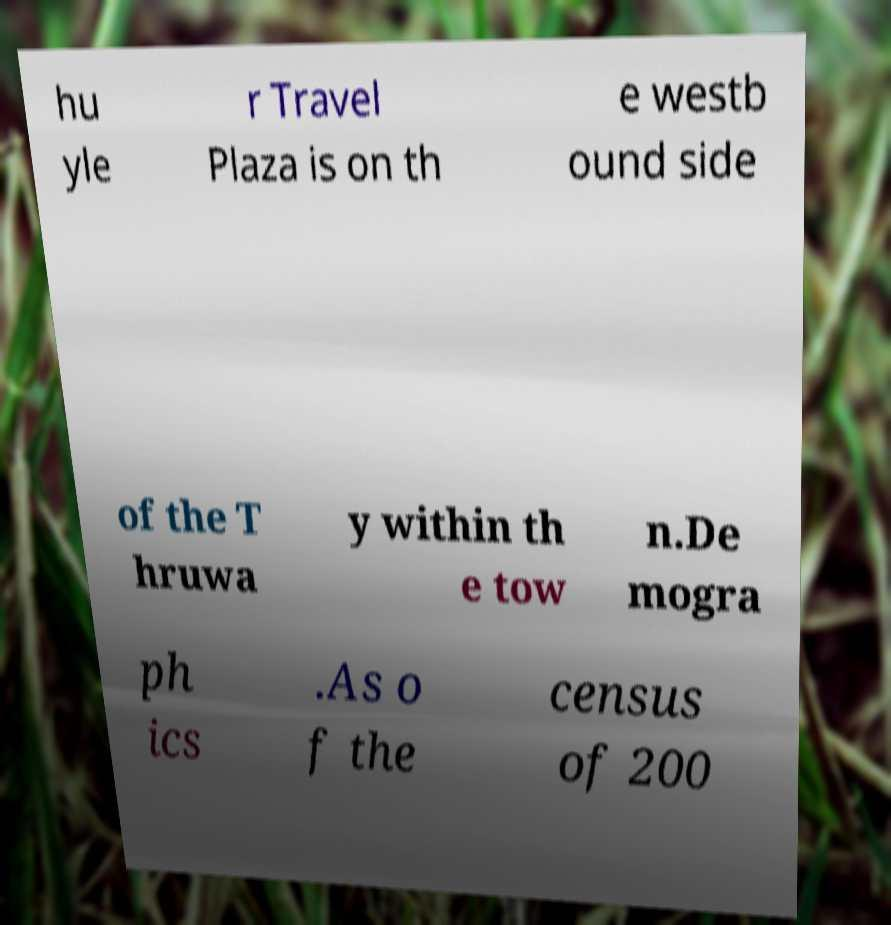Could you extract and type out the text from this image? hu yle r Travel Plaza is on th e westb ound side of the T hruwa y within th e tow n.De mogra ph ics .As o f the census of 200 